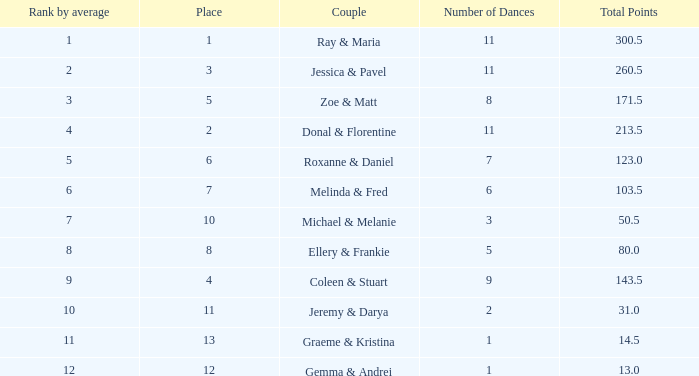What is the name of the couple with an average rank of 9? Coleen & Stuart. 